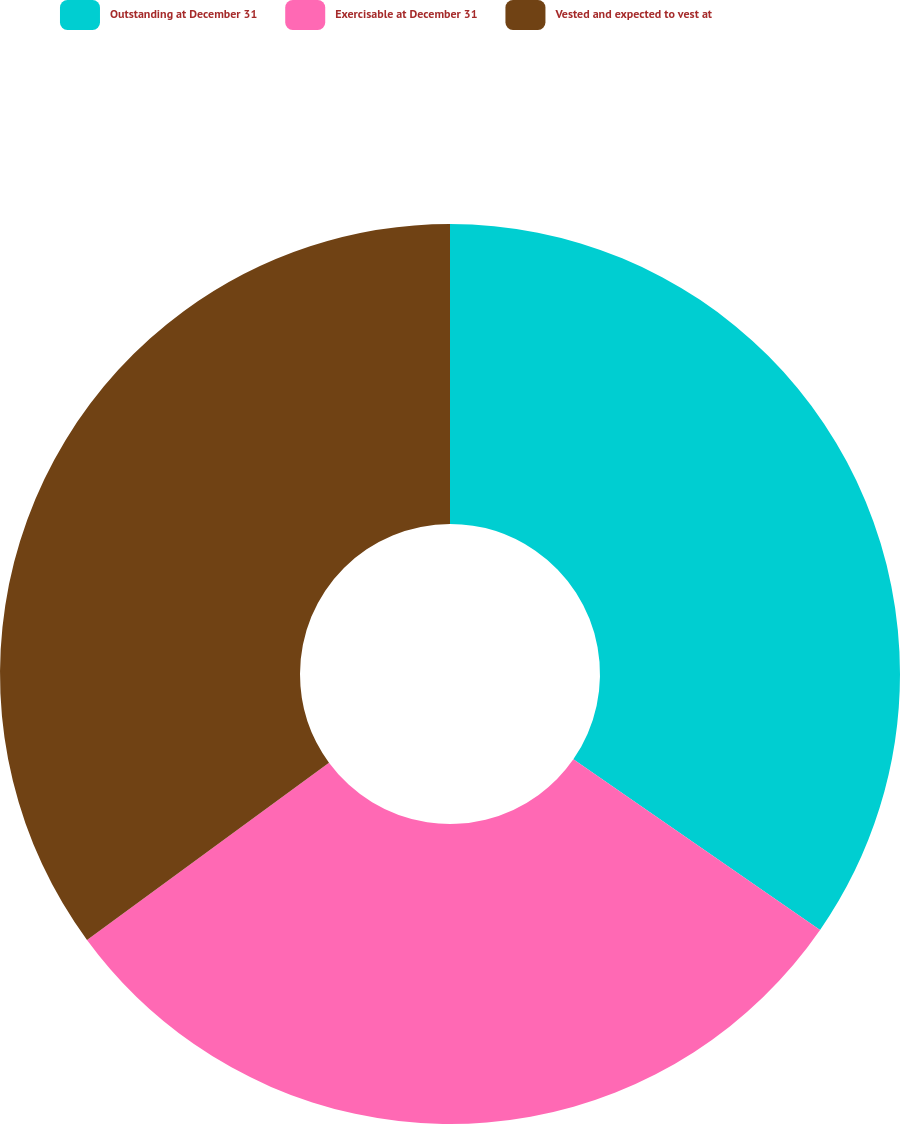Convert chart to OTSL. <chart><loc_0><loc_0><loc_500><loc_500><pie_chart><fcel>Outstanding at December 31<fcel>Exercisable at December 31<fcel>Vested and expected to vest at<nl><fcel>34.63%<fcel>30.3%<fcel>35.06%<nl></chart> 